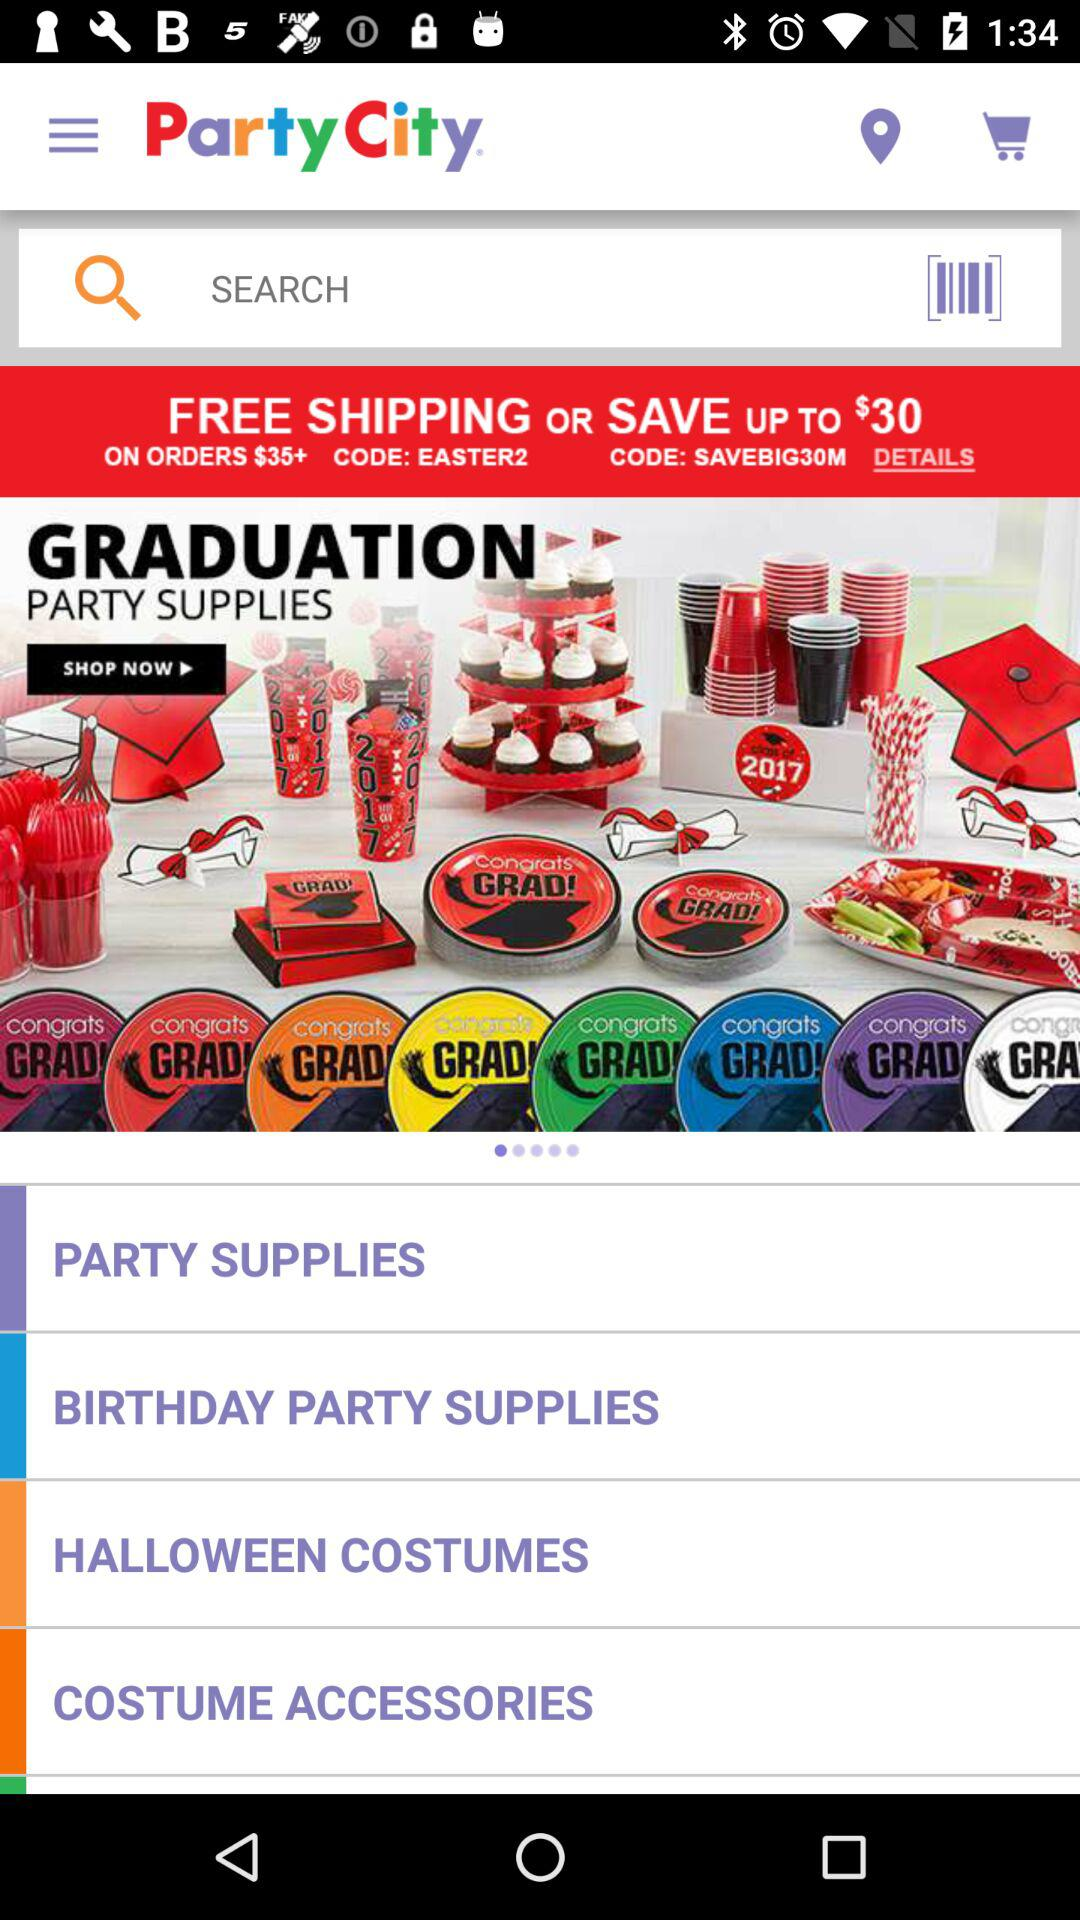What is the code for saving up to $30? The code is "SAVEBIG30M". 